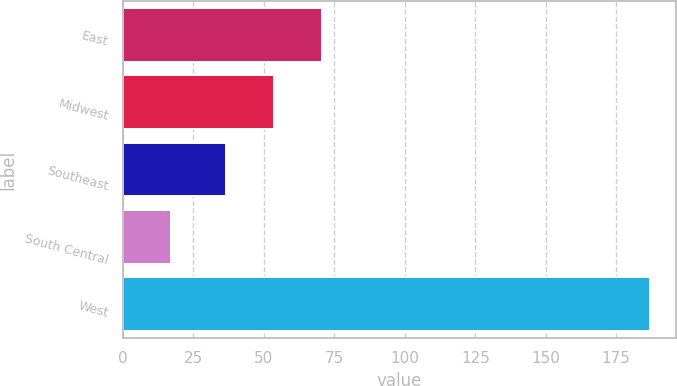<chart> <loc_0><loc_0><loc_500><loc_500><bar_chart><fcel>East<fcel>Midwest<fcel>Southeast<fcel>South Central<fcel>West<nl><fcel>70.7<fcel>53.7<fcel>36.7<fcel>17<fcel>187<nl></chart> 